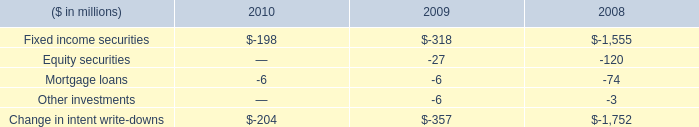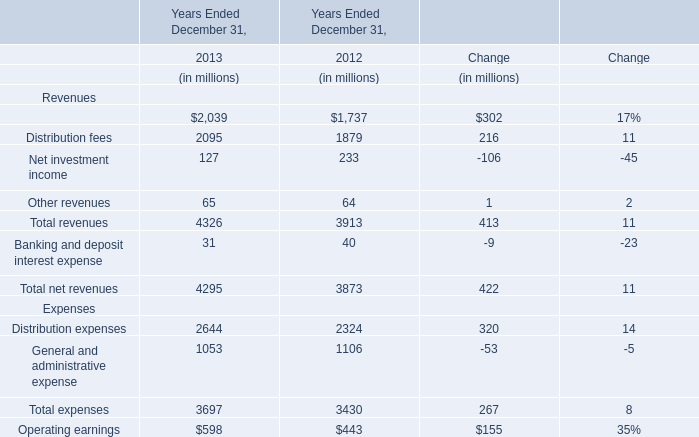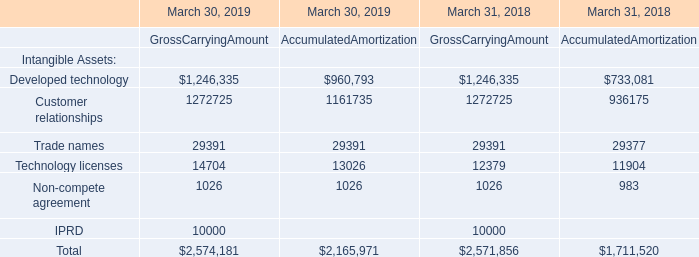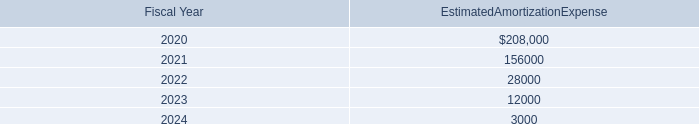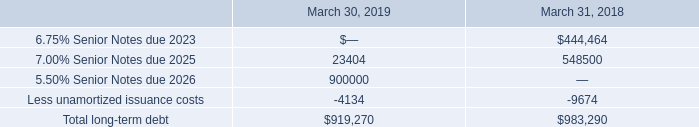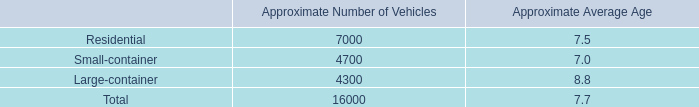What's the growth rate of Management and financial advice fees in 2013? (in %) 
Answer: 17. 